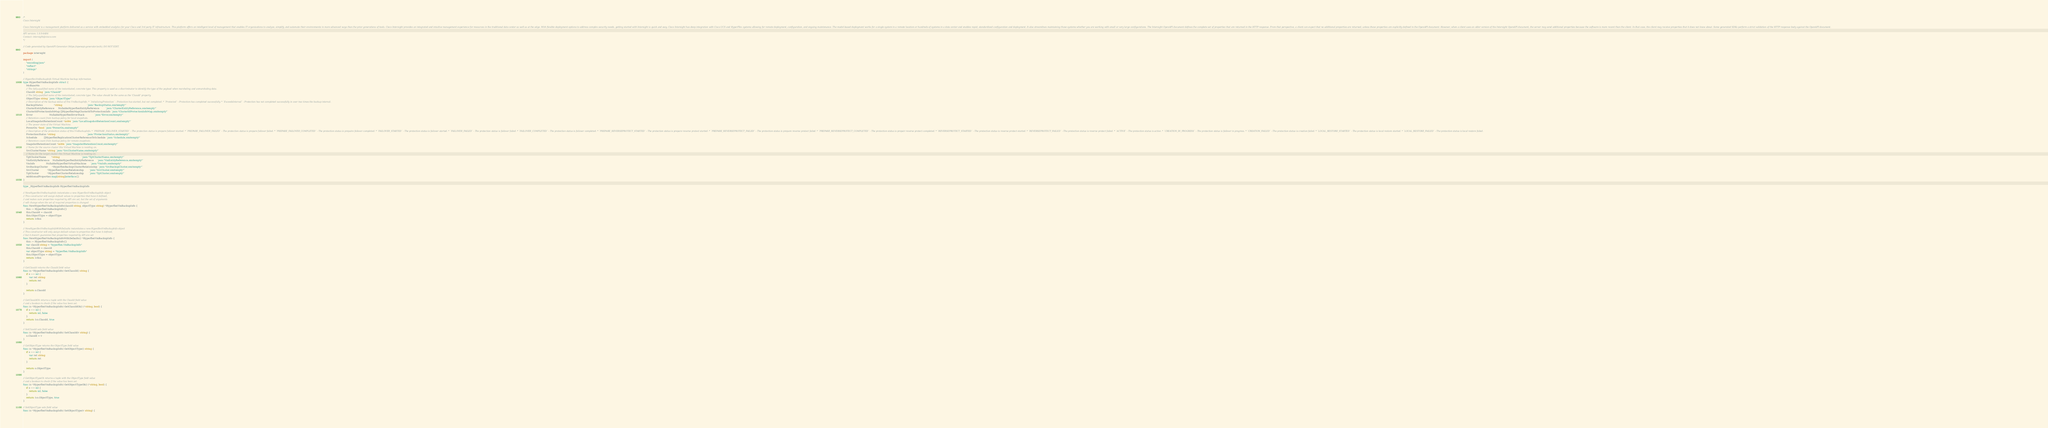Convert code to text. <code><loc_0><loc_0><loc_500><loc_500><_Go_>/*
Cisco Intersight

Cisco Intersight is a management platform delivered as a service with embedded analytics for your Cisco and 3rd party IT infrastructure. This platform offers an intelligent level of management that enables IT organizations to analyze, simplify, and automate their environments in more advanced ways than the prior generations of tools. Cisco Intersight provides an integrated and intuitive management experience for resources in the traditional data center as well as at the edge. With flexible deployment options to address complex security needs, getting started with Intersight is quick and easy. Cisco Intersight has deep integration with Cisco UCS and HyperFlex systems allowing for remote deployment, configuration, and ongoing maintenance. The model-based deployment works for a single system in a remote location or hundreds of systems in a data center and enables rapid, standardized configuration and deployment. It also streamlines maintaining those systems whether you are working with small or very large configurations. The Intersight OpenAPI document defines the complete set of properties that are returned in the HTTP response. From that perspective, a client can expect that no additional properties are returned, unless these properties are explicitly defined in the OpenAPI document. However, when a client uses an older version of the Intersight OpenAPI document, the server may send additional properties because the software is more recent than the client. In that case, the client may receive properties that it does not know about. Some generated SDKs perform a strict validation of the HTTP response body against the OpenAPI document.

API version: 1.0.9-6484
Contact: intersight@cisco.com
*/

// Code generated by OpenAPI Generator (https://openapi-generator.tech); DO NOT EDIT.

package intersight

import (
	"encoding/json"
	"reflect"
	"strings"
)

// HyperflexVmBackupInfo Virtual Machine backup information.
type HyperflexVmBackupInfo struct {
	MoBaseMo
	// The fully-qualified name of the instantiated, concrete type. This property is used as a discriminator to identify the type of the payload when marshaling and unmarshaling data.
	ClassId string `json:"ClassId"`
	// The fully-qualified name of the instantiated, concrete type. The value should be the same as the 'ClassId' property.
	ObjectType string `json:"ObjectType"`
	// Description of the backup status of this VmBackupInfo. * `InitializingProtection` - Protection has started, but not completed. * `Protected` - Protection has completed successfully. * `ExceedsInterval` - Protection has not completed successfully in over two times the backup interval.
	BackupStatus               *string                                 `json:"BackupStatus,omitempty"`
	ClusterEntityReference     NullableHyperflexEntityReference        `json:"ClusterEntityReference,omitempty"`
	ClusterIdProtectionInfoMap []HyperflexMapClusterIdToProtectionInfo `json:"ClusterIdProtectionInfoMap,omitempty"`
	Error                      NullableHyperflexErrorStack             `json:"Error,omitempty"`
	// Retention count from backup policy for local snapshots.
	LocalSnapshotRetentionCount *int64 `json:"LocalSnapshotRetentionCount,omitempty"`
	// The power state of the Virtual Machine.
	PowerOn *bool `json:"PowerOn,omitempty"`
	// Description of the protection status of this VmBackupInfo. * `PREPARE_FAILOVER_STARTED` - The protection status is prepare failover started. * `PREPARE_FAILOVER_FAILED` - The protection status is prepare failover failed. * `PREPARE_FAILOVER_COMPLETED` - The protection status is prepaire failover completed. * `FAILOVER_STARTED` - The protection status is failover started. * `FAILOVER_FAILED` - The protection status is failover failed. * `FAILOVER_COMPLETED` - The protection status is failover completed. * `PREPARE_REVERSEPROTECT_STARTED` - The protection status is prepare reverse protect started. * `PREPARE_REVERSEPROTECT_FAILED` - The protection status is prepare reverse protect failed. * `PREPARE_REVERSEPROTECT_COMPLETED` - The protection status is prepair reverse protect completed. * `REVERSEPROTECT_STARTED` - The protection status is reverse protect started. * `REVERSEPROTECT_FAILED` - The protection status is reverse protect failed. * `ACTIVE` - The protection status is active. * `CREATION_IN_PROGRESS` - The protection status is failover in progress. * `CREATION_FAILED` - The protection status is creation failed. * `LOCAL_RESTORE_STARTED` - The protection status is local restore started. * `LOCAL_RESTORE_FAILED` - The protection status is local restore failed.
	ProtectionStatus *string                                          `json:"ProtectionStatus,omitempty"`
	Schedule         []HyperflexReplicationClusterReferenceToSchedule `json:"Schedule,omitempty"`
	// Retention count from backup policy for remote snapshots.
	SnapshotRetentionCount *int64 `json:"SnapshotRetentionCount,omitempty"`
	// Name for the source cluster this Virtual Machine is residing on.
	SrcClusterName *string `json:"SrcClusterName,omitempty"`
	// Name for the target cluster this Virtual Machine is residing on.
	TgtClusterName       *string                             `json:"TgtClusterName,omitempty"`
	VmEntityReference    NullableHyperflexEntityReference    `json:"VmEntityReference,omitempty"`
	VmInfo               NullableHyperflexVirtualMachine     `json:"VmInfo,omitempty"`
	SrcBackupCluster     *HyperflexBackupClusterRelationship `json:"SrcBackupCluster,omitempty"`
	SrcCluster           *HyperflexClusterRelationship       `json:"SrcCluster,omitempty"`
	TgtCluster           *HyperflexClusterRelationship       `json:"TgtCluster,omitempty"`
	AdditionalProperties map[string]interface{}
}

type _HyperflexVmBackupInfo HyperflexVmBackupInfo

// NewHyperflexVmBackupInfo instantiates a new HyperflexVmBackupInfo object
// This constructor will assign default values to properties that have it defined,
// and makes sure properties required by API are set, but the set of arguments
// will change when the set of required properties is changed
func NewHyperflexVmBackupInfo(classId string, objectType string) *HyperflexVmBackupInfo {
	this := HyperflexVmBackupInfo{}
	this.ClassId = classId
	this.ObjectType = objectType
	return &this
}

// NewHyperflexVmBackupInfoWithDefaults instantiates a new HyperflexVmBackupInfo object
// This constructor will only assign default values to properties that have it defined,
// but it doesn't guarantee that properties required by API are set
func NewHyperflexVmBackupInfoWithDefaults() *HyperflexVmBackupInfo {
	this := HyperflexVmBackupInfo{}
	var classId string = "hyperflex.VmBackupInfo"
	this.ClassId = classId
	var objectType string = "hyperflex.VmBackupInfo"
	this.ObjectType = objectType
	return &this
}

// GetClassId returns the ClassId field value
func (o *HyperflexVmBackupInfo) GetClassId() string {
	if o == nil {
		var ret string
		return ret
	}

	return o.ClassId
}

// GetClassIdOk returns a tuple with the ClassId field value
// and a boolean to check if the value has been set.
func (o *HyperflexVmBackupInfo) GetClassIdOk() (*string, bool) {
	if o == nil {
		return nil, false
	}
	return &o.ClassId, true
}

// SetClassId sets field value
func (o *HyperflexVmBackupInfo) SetClassId(v string) {
	o.ClassId = v
}

// GetObjectType returns the ObjectType field value
func (o *HyperflexVmBackupInfo) GetObjectType() string {
	if o == nil {
		var ret string
		return ret
	}

	return o.ObjectType
}

// GetObjectTypeOk returns a tuple with the ObjectType field value
// and a boolean to check if the value has been set.
func (o *HyperflexVmBackupInfo) GetObjectTypeOk() (*string, bool) {
	if o == nil {
		return nil, false
	}
	return &o.ObjectType, true
}

// SetObjectType sets field value
func (o *HyperflexVmBackupInfo) SetObjectType(v string) {</code> 